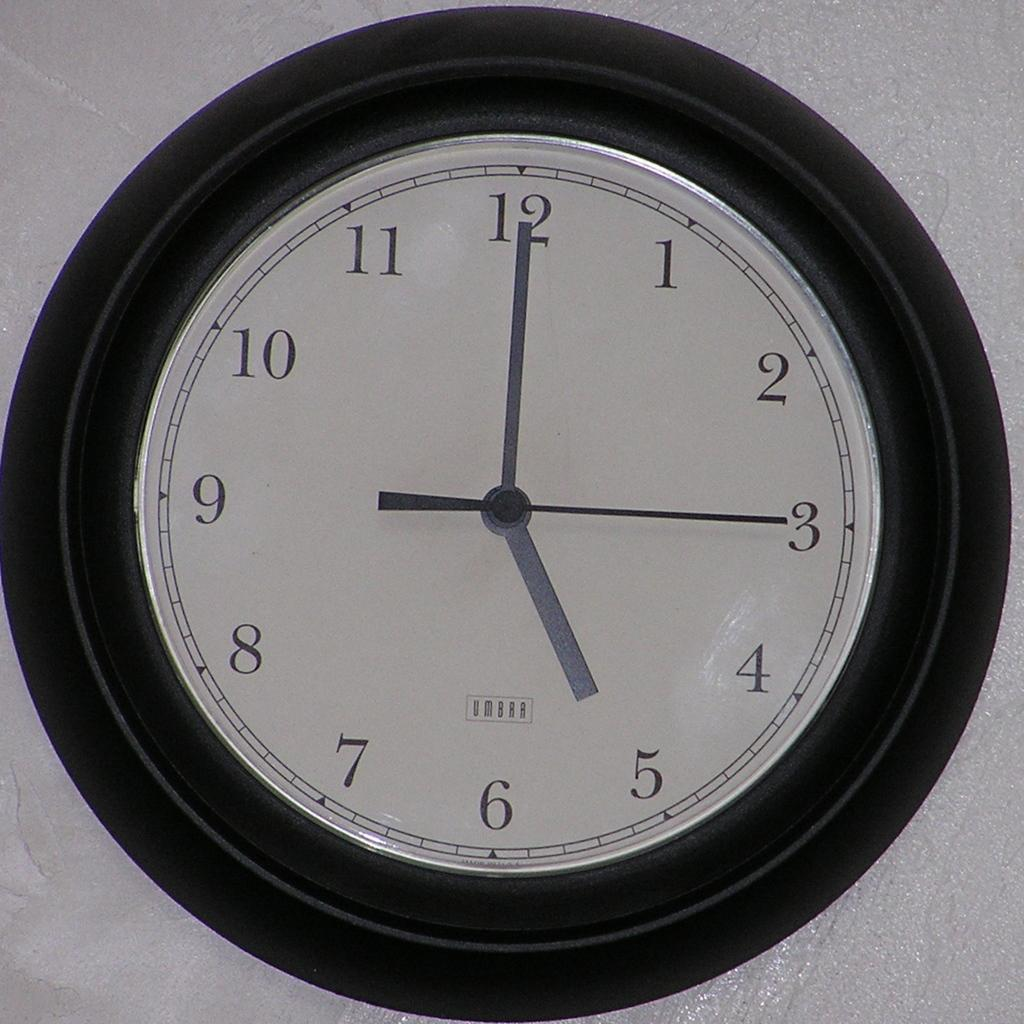<image>
Relay a brief, clear account of the picture shown. The time on an Umbra clock is now 5:00. 